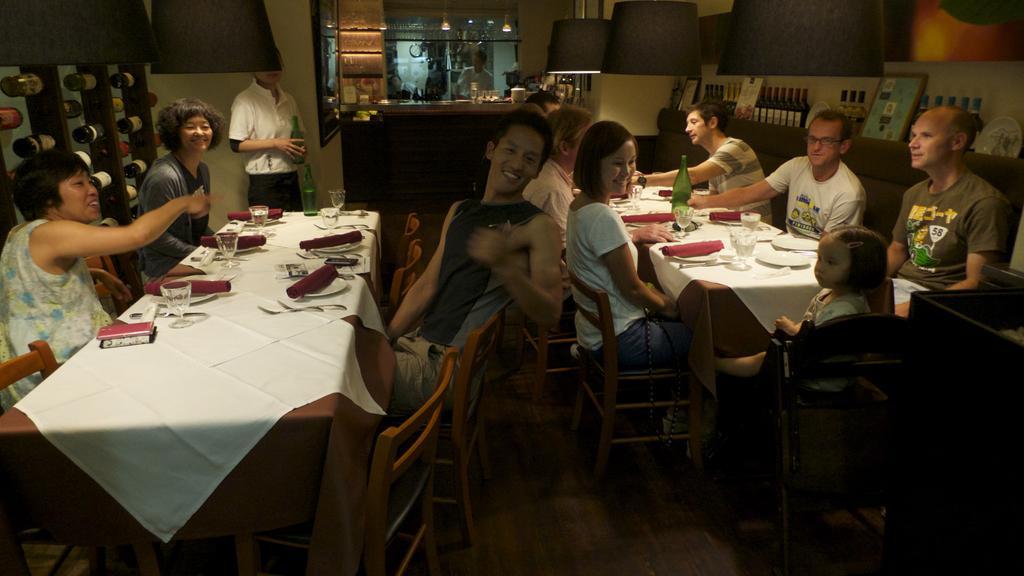Can you describe this image briefly? It looks like a restaurant group of people are sitting around the table ,on the table there are white clothes, plates ,glasses to the left side of the first table there are also bottles decorated like walls in the background there is a table and one person is standing behind the table. 